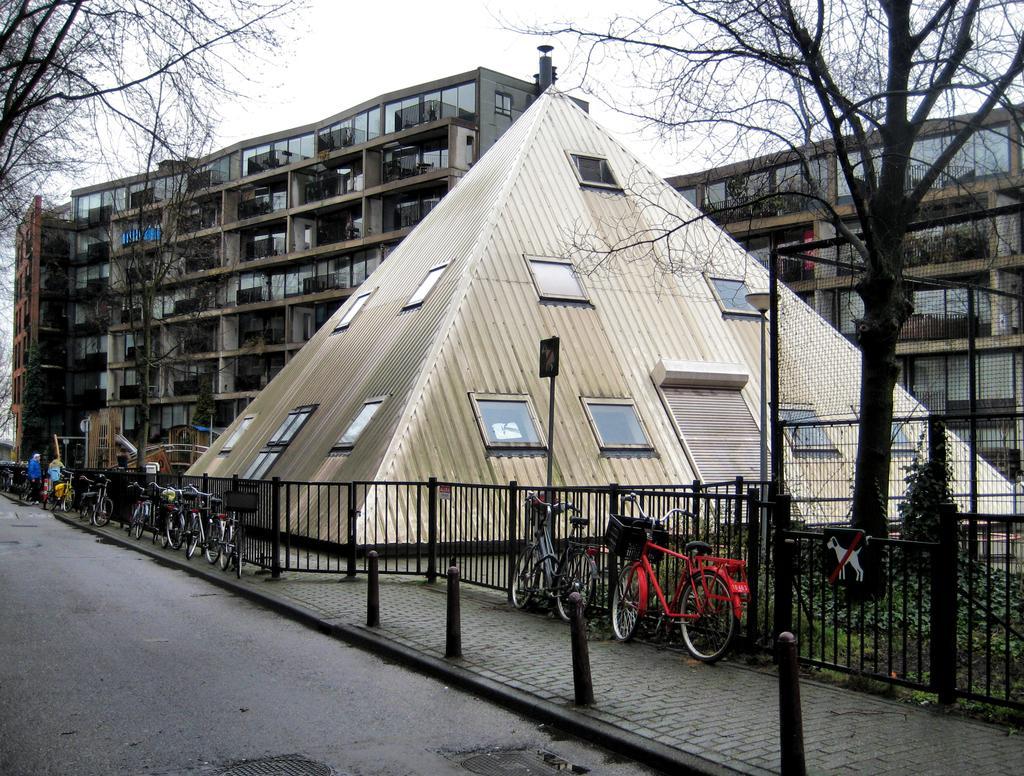Describe this image in one or two sentences. In this image, we can see an architecture and there is also a fencing and there are some bicycles which are parked in front of the fence. There are also some poles and there is a road and there are some trees and we can also see the sky. 